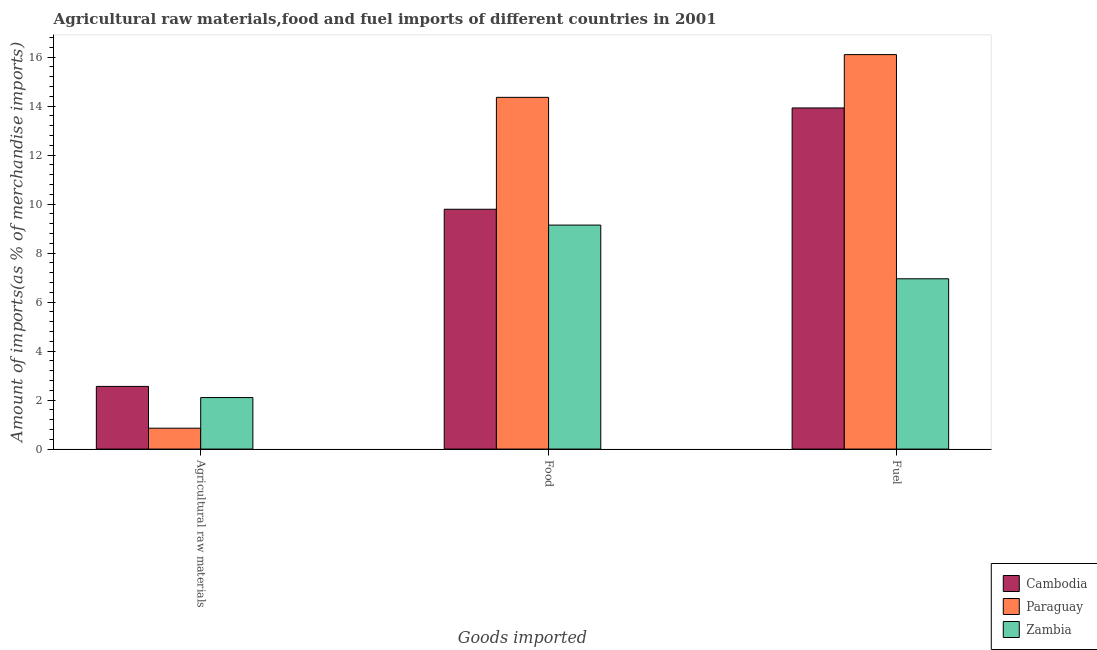How many different coloured bars are there?
Your answer should be compact. 3. Are the number of bars per tick equal to the number of legend labels?
Make the answer very short. Yes. Are the number of bars on each tick of the X-axis equal?
Keep it short and to the point. Yes. What is the label of the 3rd group of bars from the left?
Your answer should be very brief. Fuel. What is the percentage of food imports in Paraguay?
Provide a short and direct response. 14.36. Across all countries, what is the maximum percentage of raw materials imports?
Your answer should be very brief. 2.56. Across all countries, what is the minimum percentage of fuel imports?
Your answer should be very brief. 6.95. In which country was the percentage of food imports maximum?
Give a very brief answer. Paraguay. In which country was the percentage of raw materials imports minimum?
Give a very brief answer. Paraguay. What is the total percentage of raw materials imports in the graph?
Keep it short and to the point. 5.51. What is the difference between the percentage of food imports in Cambodia and that in Zambia?
Ensure brevity in your answer.  0.65. What is the difference between the percentage of food imports in Paraguay and the percentage of fuel imports in Cambodia?
Provide a short and direct response. 0.43. What is the average percentage of fuel imports per country?
Provide a short and direct response. 12.33. What is the difference between the percentage of raw materials imports and percentage of food imports in Paraguay?
Your response must be concise. -13.51. In how many countries, is the percentage of fuel imports greater than 15.2 %?
Your answer should be compact. 1. What is the ratio of the percentage of fuel imports in Zambia to that in Cambodia?
Your answer should be compact. 0.5. Is the percentage of fuel imports in Paraguay less than that in Zambia?
Provide a succinct answer. No. Is the difference between the percentage of fuel imports in Paraguay and Cambodia greater than the difference between the percentage of raw materials imports in Paraguay and Cambodia?
Your response must be concise. Yes. What is the difference between the highest and the second highest percentage of food imports?
Your answer should be compact. 4.57. What is the difference between the highest and the lowest percentage of food imports?
Keep it short and to the point. 5.21. In how many countries, is the percentage of raw materials imports greater than the average percentage of raw materials imports taken over all countries?
Your answer should be very brief. 2. What does the 3rd bar from the left in Fuel represents?
Ensure brevity in your answer.  Zambia. What does the 3rd bar from the right in Fuel represents?
Make the answer very short. Cambodia. How many countries are there in the graph?
Your answer should be compact. 3. What is the difference between two consecutive major ticks on the Y-axis?
Provide a short and direct response. 2. Does the graph contain any zero values?
Ensure brevity in your answer.  No. How many legend labels are there?
Offer a very short reply. 3. What is the title of the graph?
Your answer should be very brief. Agricultural raw materials,food and fuel imports of different countries in 2001. Does "Pacific island small states" appear as one of the legend labels in the graph?
Offer a terse response. No. What is the label or title of the X-axis?
Provide a succinct answer. Goods imported. What is the label or title of the Y-axis?
Ensure brevity in your answer.  Amount of imports(as % of merchandise imports). What is the Amount of imports(as % of merchandise imports) in Cambodia in Agricultural raw materials?
Your answer should be compact. 2.56. What is the Amount of imports(as % of merchandise imports) in Paraguay in Agricultural raw materials?
Provide a succinct answer. 0.85. What is the Amount of imports(as % of merchandise imports) in Zambia in Agricultural raw materials?
Give a very brief answer. 2.1. What is the Amount of imports(as % of merchandise imports) of Cambodia in Food?
Offer a very short reply. 9.79. What is the Amount of imports(as % of merchandise imports) of Paraguay in Food?
Provide a short and direct response. 14.36. What is the Amount of imports(as % of merchandise imports) of Zambia in Food?
Offer a terse response. 9.14. What is the Amount of imports(as % of merchandise imports) in Cambodia in Fuel?
Offer a very short reply. 13.93. What is the Amount of imports(as % of merchandise imports) of Paraguay in Fuel?
Make the answer very short. 16.1. What is the Amount of imports(as % of merchandise imports) in Zambia in Fuel?
Make the answer very short. 6.95. Across all Goods imported, what is the maximum Amount of imports(as % of merchandise imports) of Cambodia?
Ensure brevity in your answer.  13.93. Across all Goods imported, what is the maximum Amount of imports(as % of merchandise imports) in Paraguay?
Your answer should be compact. 16.1. Across all Goods imported, what is the maximum Amount of imports(as % of merchandise imports) in Zambia?
Keep it short and to the point. 9.14. Across all Goods imported, what is the minimum Amount of imports(as % of merchandise imports) of Cambodia?
Offer a terse response. 2.56. Across all Goods imported, what is the minimum Amount of imports(as % of merchandise imports) in Paraguay?
Make the answer very short. 0.85. Across all Goods imported, what is the minimum Amount of imports(as % of merchandise imports) in Zambia?
Provide a succinct answer. 2.1. What is the total Amount of imports(as % of merchandise imports) in Cambodia in the graph?
Provide a succinct answer. 26.27. What is the total Amount of imports(as % of merchandise imports) of Paraguay in the graph?
Make the answer very short. 31.31. What is the total Amount of imports(as % of merchandise imports) of Zambia in the graph?
Give a very brief answer. 18.2. What is the difference between the Amount of imports(as % of merchandise imports) of Cambodia in Agricultural raw materials and that in Food?
Your answer should be very brief. -7.23. What is the difference between the Amount of imports(as % of merchandise imports) of Paraguay in Agricultural raw materials and that in Food?
Your answer should be compact. -13.51. What is the difference between the Amount of imports(as % of merchandise imports) of Zambia in Agricultural raw materials and that in Food?
Provide a succinct answer. -7.04. What is the difference between the Amount of imports(as % of merchandise imports) of Cambodia in Agricultural raw materials and that in Fuel?
Your answer should be very brief. -11.37. What is the difference between the Amount of imports(as % of merchandise imports) of Paraguay in Agricultural raw materials and that in Fuel?
Offer a very short reply. -15.25. What is the difference between the Amount of imports(as % of merchandise imports) in Zambia in Agricultural raw materials and that in Fuel?
Your answer should be compact. -4.85. What is the difference between the Amount of imports(as % of merchandise imports) in Cambodia in Food and that in Fuel?
Offer a very short reply. -4.14. What is the difference between the Amount of imports(as % of merchandise imports) of Paraguay in Food and that in Fuel?
Keep it short and to the point. -1.75. What is the difference between the Amount of imports(as % of merchandise imports) of Zambia in Food and that in Fuel?
Make the answer very short. 2.19. What is the difference between the Amount of imports(as % of merchandise imports) in Cambodia in Agricultural raw materials and the Amount of imports(as % of merchandise imports) in Paraguay in Food?
Give a very brief answer. -11.8. What is the difference between the Amount of imports(as % of merchandise imports) in Cambodia in Agricultural raw materials and the Amount of imports(as % of merchandise imports) in Zambia in Food?
Ensure brevity in your answer.  -6.59. What is the difference between the Amount of imports(as % of merchandise imports) in Paraguay in Agricultural raw materials and the Amount of imports(as % of merchandise imports) in Zambia in Food?
Offer a very short reply. -8.29. What is the difference between the Amount of imports(as % of merchandise imports) in Cambodia in Agricultural raw materials and the Amount of imports(as % of merchandise imports) in Paraguay in Fuel?
Give a very brief answer. -13.54. What is the difference between the Amount of imports(as % of merchandise imports) in Cambodia in Agricultural raw materials and the Amount of imports(as % of merchandise imports) in Zambia in Fuel?
Offer a very short reply. -4.39. What is the difference between the Amount of imports(as % of merchandise imports) of Paraguay in Agricultural raw materials and the Amount of imports(as % of merchandise imports) of Zambia in Fuel?
Your answer should be very brief. -6.1. What is the difference between the Amount of imports(as % of merchandise imports) in Cambodia in Food and the Amount of imports(as % of merchandise imports) in Paraguay in Fuel?
Make the answer very short. -6.31. What is the difference between the Amount of imports(as % of merchandise imports) of Cambodia in Food and the Amount of imports(as % of merchandise imports) of Zambia in Fuel?
Offer a terse response. 2.84. What is the difference between the Amount of imports(as % of merchandise imports) of Paraguay in Food and the Amount of imports(as % of merchandise imports) of Zambia in Fuel?
Your answer should be very brief. 7.41. What is the average Amount of imports(as % of merchandise imports) in Cambodia per Goods imported?
Your answer should be compact. 8.76. What is the average Amount of imports(as % of merchandise imports) of Paraguay per Goods imported?
Make the answer very short. 10.44. What is the average Amount of imports(as % of merchandise imports) in Zambia per Goods imported?
Give a very brief answer. 6.07. What is the difference between the Amount of imports(as % of merchandise imports) in Cambodia and Amount of imports(as % of merchandise imports) in Paraguay in Agricultural raw materials?
Your response must be concise. 1.71. What is the difference between the Amount of imports(as % of merchandise imports) of Cambodia and Amount of imports(as % of merchandise imports) of Zambia in Agricultural raw materials?
Provide a succinct answer. 0.46. What is the difference between the Amount of imports(as % of merchandise imports) in Paraguay and Amount of imports(as % of merchandise imports) in Zambia in Agricultural raw materials?
Provide a short and direct response. -1.25. What is the difference between the Amount of imports(as % of merchandise imports) of Cambodia and Amount of imports(as % of merchandise imports) of Paraguay in Food?
Make the answer very short. -4.57. What is the difference between the Amount of imports(as % of merchandise imports) of Cambodia and Amount of imports(as % of merchandise imports) of Zambia in Food?
Ensure brevity in your answer.  0.65. What is the difference between the Amount of imports(as % of merchandise imports) of Paraguay and Amount of imports(as % of merchandise imports) of Zambia in Food?
Make the answer very short. 5.21. What is the difference between the Amount of imports(as % of merchandise imports) of Cambodia and Amount of imports(as % of merchandise imports) of Paraguay in Fuel?
Your response must be concise. -2.18. What is the difference between the Amount of imports(as % of merchandise imports) in Cambodia and Amount of imports(as % of merchandise imports) in Zambia in Fuel?
Provide a short and direct response. 6.97. What is the difference between the Amount of imports(as % of merchandise imports) in Paraguay and Amount of imports(as % of merchandise imports) in Zambia in Fuel?
Your response must be concise. 9.15. What is the ratio of the Amount of imports(as % of merchandise imports) of Cambodia in Agricultural raw materials to that in Food?
Keep it short and to the point. 0.26. What is the ratio of the Amount of imports(as % of merchandise imports) of Paraguay in Agricultural raw materials to that in Food?
Keep it short and to the point. 0.06. What is the ratio of the Amount of imports(as % of merchandise imports) of Zambia in Agricultural raw materials to that in Food?
Keep it short and to the point. 0.23. What is the ratio of the Amount of imports(as % of merchandise imports) of Cambodia in Agricultural raw materials to that in Fuel?
Your answer should be compact. 0.18. What is the ratio of the Amount of imports(as % of merchandise imports) in Paraguay in Agricultural raw materials to that in Fuel?
Your answer should be compact. 0.05. What is the ratio of the Amount of imports(as % of merchandise imports) of Zambia in Agricultural raw materials to that in Fuel?
Give a very brief answer. 0.3. What is the ratio of the Amount of imports(as % of merchandise imports) of Cambodia in Food to that in Fuel?
Your answer should be very brief. 0.7. What is the ratio of the Amount of imports(as % of merchandise imports) of Paraguay in Food to that in Fuel?
Offer a terse response. 0.89. What is the ratio of the Amount of imports(as % of merchandise imports) of Zambia in Food to that in Fuel?
Your response must be concise. 1.32. What is the difference between the highest and the second highest Amount of imports(as % of merchandise imports) in Cambodia?
Offer a very short reply. 4.14. What is the difference between the highest and the second highest Amount of imports(as % of merchandise imports) in Paraguay?
Provide a short and direct response. 1.75. What is the difference between the highest and the second highest Amount of imports(as % of merchandise imports) in Zambia?
Provide a succinct answer. 2.19. What is the difference between the highest and the lowest Amount of imports(as % of merchandise imports) of Cambodia?
Ensure brevity in your answer.  11.37. What is the difference between the highest and the lowest Amount of imports(as % of merchandise imports) in Paraguay?
Provide a succinct answer. 15.25. What is the difference between the highest and the lowest Amount of imports(as % of merchandise imports) of Zambia?
Your answer should be very brief. 7.04. 